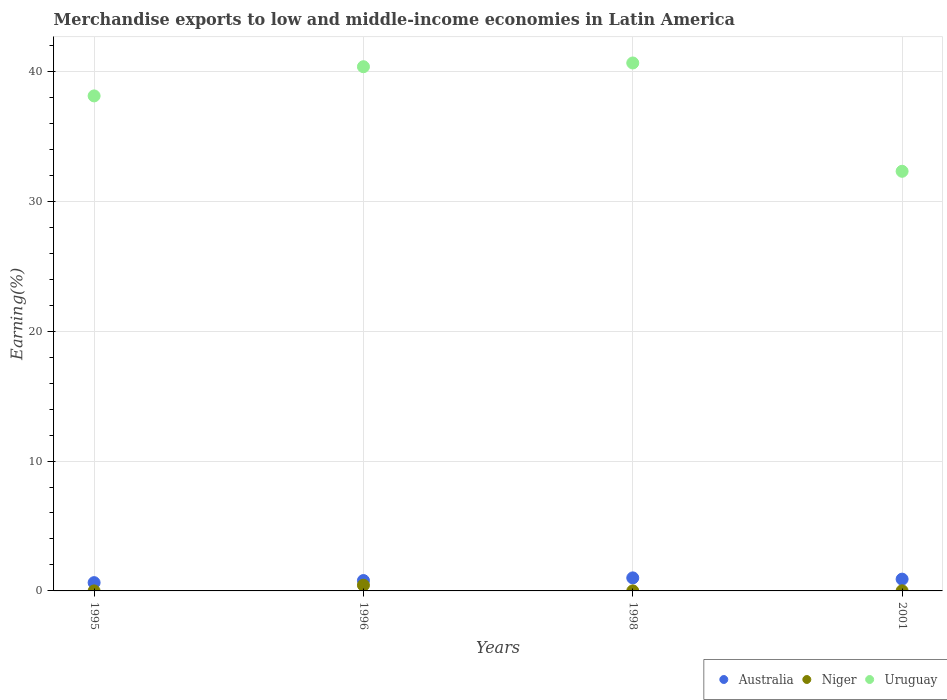How many different coloured dotlines are there?
Give a very brief answer. 3. Is the number of dotlines equal to the number of legend labels?
Make the answer very short. Yes. What is the percentage of amount earned from merchandise exports in Australia in 1998?
Ensure brevity in your answer.  1. Across all years, what is the maximum percentage of amount earned from merchandise exports in Uruguay?
Provide a short and direct response. 40.65. Across all years, what is the minimum percentage of amount earned from merchandise exports in Niger?
Give a very brief answer. 0. In which year was the percentage of amount earned from merchandise exports in Niger maximum?
Offer a very short reply. 1996. What is the total percentage of amount earned from merchandise exports in Niger in the graph?
Make the answer very short. 0.45. What is the difference between the percentage of amount earned from merchandise exports in Uruguay in 1995 and that in 1998?
Ensure brevity in your answer.  -2.54. What is the difference between the percentage of amount earned from merchandise exports in Niger in 1995 and the percentage of amount earned from merchandise exports in Uruguay in 2001?
Keep it short and to the point. -32.31. What is the average percentage of amount earned from merchandise exports in Uruguay per year?
Your response must be concise. 37.86. In the year 1998, what is the difference between the percentage of amount earned from merchandise exports in Niger and percentage of amount earned from merchandise exports in Uruguay?
Offer a terse response. -40.65. In how many years, is the percentage of amount earned from merchandise exports in Niger greater than 16 %?
Your answer should be compact. 0. What is the ratio of the percentage of amount earned from merchandise exports in Niger in 1998 to that in 2001?
Offer a very short reply. 0.39. Is the percentage of amount earned from merchandise exports in Uruguay in 1995 less than that in 2001?
Your response must be concise. No. What is the difference between the highest and the second highest percentage of amount earned from merchandise exports in Niger?
Your answer should be compact. 0.43. What is the difference between the highest and the lowest percentage of amount earned from merchandise exports in Niger?
Offer a very short reply. 0.44. In how many years, is the percentage of amount earned from merchandise exports in Niger greater than the average percentage of amount earned from merchandise exports in Niger taken over all years?
Give a very brief answer. 1. Is it the case that in every year, the sum of the percentage of amount earned from merchandise exports in Uruguay and percentage of amount earned from merchandise exports in Niger  is greater than the percentage of amount earned from merchandise exports in Australia?
Provide a succinct answer. Yes. How many years are there in the graph?
Your answer should be compact. 4. Does the graph contain any zero values?
Offer a very short reply. No. How many legend labels are there?
Keep it short and to the point. 3. How are the legend labels stacked?
Your answer should be compact. Horizontal. What is the title of the graph?
Your response must be concise. Merchandise exports to low and middle-income economies in Latin America. What is the label or title of the X-axis?
Offer a very short reply. Years. What is the label or title of the Y-axis?
Offer a terse response. Earning(%). What is the Earning(%) of Australia in 1995?
Give a very brief answer. 0.64. What is the Earning(%) in Niger in 1995?
Provide a succinct answer. 0. What is the Earning(%) in Uruguay in 1995?
Keep it short and to the point. 38.11. What is the Earning(%) of Australia in 1996?
Offer a very short reply. 0.8. What is the Earning(%) of Niger in 1996?
Give a very brief answer. 0.44. What is the Earning(%) in Uruguay in 1996?
Offer a terse response. 40.36. What is the Earning(%) of Australia in 1998?
Keep it short and to the point. 1. What is the Earning(%) of Niger in 1998?
Ensure brevity in your answer.  0. What is the Earning(%) of Uruguay in 1998?
Your answer should be very brief. 40.65. What is the Earning(%) of Australia in 2001?
Give a very brief answer. 0.91. What is the Earning(%) of Niger in 2001?
Provide a short and direct response. 0.01. What is the Earning(%) of Uruguay in 2001?
Your answer should be very brief. 32.31. Across all years, what is the maximum Earning(%) in Australia?
Your response must be concise. 1. Across all years, what is the maximum Earning(%) of Niger?
Offer a very short reply. 0.44. Across all years, what is the maximum Earning(%) of Uruguay?
Keep it short and to the point. 40.65. Across all years, what is the minimum Earning(%) of Australia?
Offer a terse response. 0.64. Across all years, what is the minimum Earning(%) in Niger?
Keep it short and to the point. 0. Across all years, what is the minimum Earning(%) of Uruguay?
Provide a short and direct response. 32.31. What is the total Earning(%) of Australia in the graph?
Provide a short and direct response. 3.35. What is the total Earning(%) in Niger in the graph?
Make the answer very short. 0.45. What is the total Earning(%) in Uruguay in the graph?
Make the answer very short. 151.44. What is the difference between the Earning(%) of Australia in 1995 and that in 1996?
Keep it short and to the point. -0.16. What is the difference between the Earning(%) in Niger in 1995 and that in 1996?
Provide a succinct answer. -0.44. What is the difference between the Earning(%) of Uruguay in 1995 and that in 1996?
Your response must be concise. -2.25. What is the difference between the Earning(%) in Australia in 1995 and that in 1998?
Your answer should be very brief. -0.37. What is the difference between the Earning(%) of Niger in 1995 and that in 1998?
Offer a very short reply. -0. What is the difference between the Earning(%) in Uruguay in 1995 and that in 1998?
Your answer should be very brief. -2.54. What is the difference between the Earning(%) in Australia in 1995 and that in 2001?
Keep it short and to the point. -0.27. What is the difference between the Earning(%) of Niger in 1995 and that in 2001?
Provide a succinct answer. -0.01. What is the difference between the Earning(%) of Uruguay in 1995 and that in 2001?
Ensure brevity in your answer.  5.8. What is the difference between the Earning(%) in Australia in 1996 and that in 1998?
Your answer should be compact. -0.21. What is the difference between the Earning(%) in Niger in 1996 and that in 1998?
Give a very brief answer. 0.44. What is the difference between the Earning(%) in Uruguay in 1996 and that in 1998?
Provide a short and direct response. -0.29. What is the difference between the Earning(%) of Australia in 1996 and that in 2001?
Provide a short and direct response. -0.11. What is the difference between the Earning(%) of Niger in 1996 and that in 2001?
Provide a succinct answer. 0.43. What is the difference between the Earning(%) in Uruguay in 1996 and that in 2001?
Your answer should be very brief. 8.05. What is the difference between the Earning(%) in Australia in 1998 and that in 2001?
Your response must be concise. 0.1. What is the difference between the Earning(%) in Niger in 1998 and that in 2001?
Make the answer very short. -0.01. What is the difference between the Earning(%) in Uruguay in 1998 and that in 2001?
Your response must be concise. 8.34. What is the difference between the Earning(%) in Australia in 1995 and the Earning(%) in Niger in 1996?
Give a very brief answer. 0.2. What is the difference between the Earning(%) in Australia in 1995 and the Earning(%) in Uruguay in 1996?
Keep it short and to the point. -39.72. What is the difference between the Earning(%) of Niger in 1995 and the Earning(%) of Uruguay in 1996?
Your answer should be very brief. -40.36. What is the difference between the Earning(%) of Australia in 1995 and the Earning(%) of Niger in 1998?
Ensure brevity in your answer.  0.63. What is the difference between the Earning(%) of Australia in 1995 and the Earning(%) of Uruguay in 1998?
Give a very brief answer. -40.01. What is the difference between the Earning(%) of Niger in 1995 and the Earning(%) of Uruguay in 1998?
Make the answer very short. -40.65. What is the difference between the Earning(%) in Australia in 1995 and the Earning(%) in Niger in 2001?
Provide a short and direct response. 0.63. What is the difference between the Earning(%) of Australia in 1995 and the Earning(%) of Uruguay in 2001?
Your response must be concise. -31.67. What is the difference between the Earning(%) of Niger in 1995 and the Earning(%) of Uruguay in 2001?
Offer a very short reply. -32.31. What is the difference between the Earning(%) of Australia in 1996 and the Earning(%) of Niger in 1998?
Ensure brevity in your answer.  0.8. What is the difference between the Earning(%) of Australia in 1996 and the Earning(%) of Uruguay in 1998?
Keep it short and to the point. -39.85. What is the difference between the Earning(%) of Niger in 1996 and the Earning(%) of Uruguay in 1998?
Give a very brief answer. -40.21. What is the difference between the Earning(%) in Australia in 1996 and the Earning(%) in Niger in 2001?
Provide a short and direct response. 0.79. What is the difference between the Earning(%) of Australia in 1996 and the Earning(%) of Uruguay in 2001?
Keep it short and to the point. -31.51. What is the difference between the Earning(%) of Niger in 1996 and the Earning(%) of Uruguay in 2001?
Keep it short and to the point. -31.87. What is the difference between the Earning(%) in Australia in 1998 and the Earning(%) in Niger in 2001?
Offer a terse response. 1. What is the difference between the Earning(%) in Australia in 1998 and the Earning(%) in Uruguay in 2001?
Keep it short and to the point. -31.31. What is the difference between the Earning(%) in Niger in 1998 and the Earning(%) in Uruguay in 2001?
Give a very brief answer. -32.31. What is the average Earning(%) of Australia per year?
Offer a very short reply. 0.84. What is the average Earning(%) of Niger per year?
Provide a succinct answer. 0.11. What is the average Earning(%) of Uruguay per year?
Your answer should be compact. 37.86. In the year 1995, what is the difference between the Earning(%) of Australia and Earning(%) of Niger?
Your answer should be very brief. 0.64. In the year 1995, what is the difference between the Earning(%) in Australia and Earning(%) in Uruguay?
Your answer should be compact. -37.48. In the year 1995, what is the difference between the Earning(%) in Niger and Earning(%) in Uruguay?
Provide a succinct answer. -38.11. In the year 1996, what is the difference between the Earning(%) of Australia and Earning(%) of Niger?
Keep it short and to the point. 0.36. In the year 1996, what is the difference between the Earning(%) in Australia and Earning(%) in Uruguay?
Provide a short and direct response. -39.56. In the year 1996, what is the difference between the Earning(%) of Niger and Earning(%) of Uruguay?
Keep it short and to the point. -39.92. In the year 1998, what is the difference between the Earning(%) in Australia and Earning(%) in Niger?
Offer a very short reply. 1. In the year 1998, what is the difference between the Earning(%) in Australia and Earning(%) in Uruguay?
Your response must be concise. -39.65. In the year 1998, what is the difference between the Earning(%) of Niger and Earning(%) of Uruguay?
Your response must be concise. -40.65. In the year 2001, what is the difference between the Earning(%) in Australia and Earning(%) in Niger?
Your answer should be very brief. 0.9. In the year 2001, what is the difference between the Earning(%) in Australia and Earning(%) in Uruguay?
Provide a short and direct response. -31.4. In the year 2001, what is the difference between the Earning(%) in Niger and Earning(%) in Uruguay?
Your answer should be compact. -32.3. What is the ratio of the Earning(%) of Australia in 1995 to that in 1996?
Make the answer very short. 0.8. What is the ratio of the Earning(%) in Niger in 1995 to that in 1996?
Provide a succinct answer. 0. What is the ratio of the Earning(%) in Uruguay in 1995 to that in 1996?
Make the answer very short. 0.94. What is the ratio of the Earning(%) of Australia in 1995 to that in 1998?
Make the answer very short. 0.64. What is the ratio of the Earning(%) in Niger in 1995 to that in 1998?
Offer a terse response. 0.32. What is the ratio of the Earning(%) of Uruguay in 1995 to that in 1998?
Offer a terse response. 0.94. What is the ratio of the Earning(%) of Australia in 1995 to that in 2001?
Give a very brief answer. 0.7. What is the ratio of the Earning(%) in Niger in 1995 to that in 2001?
Provide a succinct answer. 0.12. What is the ratio of the Earning(%) in Uruguay in 1995 to that in 2001?
Your response must be concise. 1.18. What is the ratio of the Earning(%) of Australia in 1996 to that in 1998?
Offer a terse response. 0.8. What is the ratio of the Earning(%) in Niger in 1996 to that in 1998?
Make the answer very short. 134.07. What is the ratio of the Earning(%) in Australia in 1996 to that in 2001?
Provide a short and direct response. 0.88. What is the ratio of the Earning(%) of Niger in 1996 to that in 2001?
Make the answer very short. 51.82. What is the ratio of the Earning(%) in Uruguay in 1996 to that in 2001?
Offer a very short reply. 1.25. What is the ratio of the Earning(%) of Australia in 1998 to that in 2001?
Your answer should be compact. 1.11. What is the ratio of the Earning(%) of Niger in 1998 to that in 2001?
Offer a very short reply. 0.39. What is the ratio of the Earning(%) of Uruguay in 1998 to that in 2001?
Give a very brief answer. 1.26. What is the difference between the highest and the second highest Earning(%) of Australia?
Provide a short and direct response. 0.1. What is the difference between the highest and the second highest Earning(%) in Niger?
Give a very brief answer. 0.43. What is the difference between the highest and the second highest Earning(%) of Uruguay?
Offer a very short reply. 0.29. What is the difference between the highest and the lowest Earning(%) of Australia?
Provide a succinct answer. 0.37. What is the difference between the highest and the lowest Earning(%) of Niger?
Provide a short and direct response. 0.44. What is the difference between the highest and the lowest Earning(%) in Uruguay?
Your answer should be compact. 8.34. 